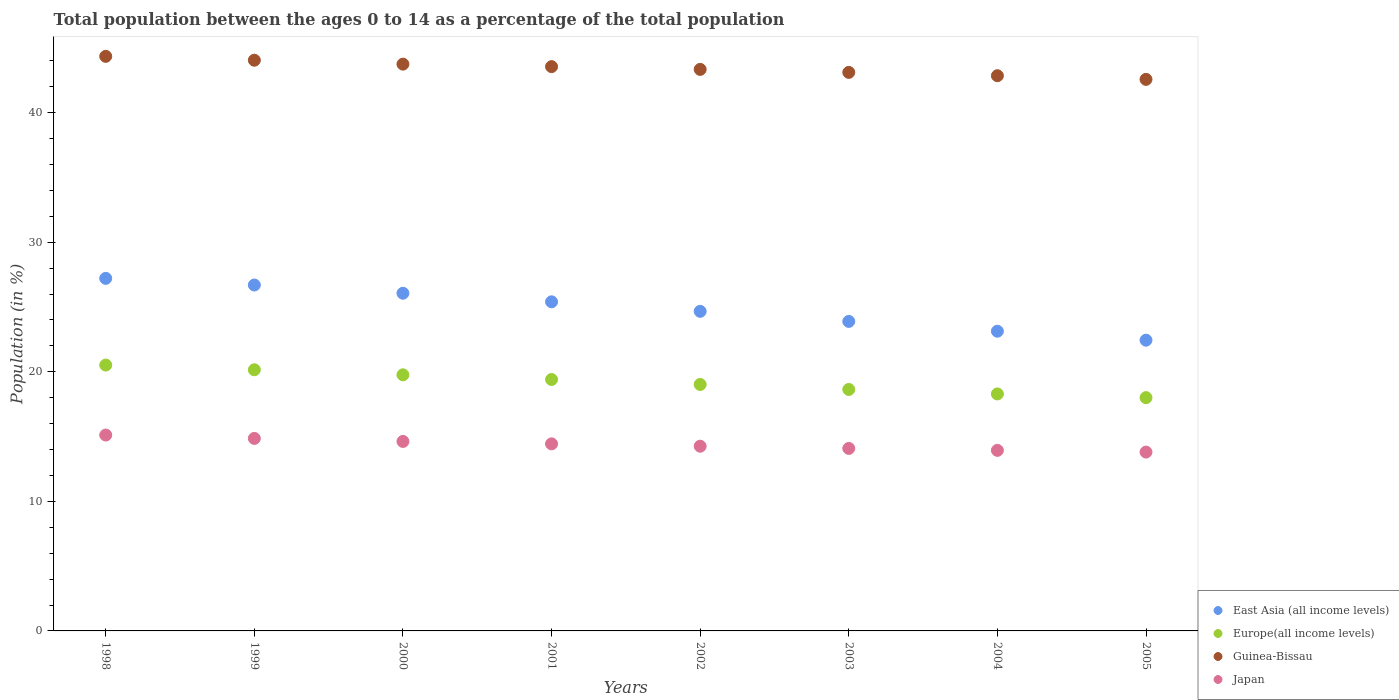How many different coloured dotlines are there?
Keep it short and to the point. 4. What is the percentage of the population ages 0 to 14 in Guinea-Bissau in 2004?
Your response must be concise. 42.85. Across all years, what is the maximum percentage of the population ages 0 to 14 in Europe(all income levels)?
Ensure brevity in your answer.  20.52. Across all years, what is the minimum percentage of the population ages 0 to 14 in Japan?
Your response must be concise. 13.8. In which year was the percentage of the population ages 0 to 14 in Guinea-Bissau maximum?
Your answer should be compact. 1998. In which year was the percentage of the population ages 0 to 14 in East Asia (all income levels) minimum?
Ensure brevity in your answer.  2005. What is the total percentage of the population ages 0 to 14 in Japan in the graph?
Your answer should be very brief. 115.12. What is the difference between the percentage of the population ages 0 to 14 in Guinea-Bissau in 2000 and that in 2003?
Your response must be concise. 0.64. What is the difference between the percentage of the population ages 0 to 14 in Guinea-Bissau in 1998 and the percentage of the population ages 0 to 14 in East Asia (all income levels) in 2002?
Offer a very short reply. 19.68. What is the average percentage of the population ages 0 to 14 in East Asia (all income levels) per year?
Offer a terse response. 24.94. In the year 1998, what is the difference between the percentage of the population ages 0 to 14 in Guinea-Bissau and percentage of the population ages 0 to 14 in East Asia (all income levels)?
Keep it short and to the point. 17.13. In how many years, is the percentage of the population ages 0 to 14 in Europe(all income levels) greater than 6?
Ensure brevity in your answer.  8. What is the ratio of the percentage of the population ages 0 to 14 in Japan in 1998 to that in 1999?
Provide a succinct answer. 1.02. Is the percentage of the population ages 0 to 14 in Europe(all income levels) in 2000 less than that in 2002?
Offer a very short reply. No. What is the difference between the highest and the second highest percentage of the population ages 0 to 14 in Japan?
Offer a very short reply. 0.26. What is the difference between the highest and the lowest percentage of the population ages 0 to 14 in East Asia (all income levels)?
Provide a succinct answer. 4.77. In how many years, is the percentage of the population ages 0 to 14 in Europe(all income levels) greater than the average percentage of the population ages 0 to 14 in Europe(all income levels) taken over all years?
Provide a succinct answer. 4. Is it the case that in every year, the sum of the percentage of the population ages 0 to 14 in Europe(all income levels) and percentage of the population ages 0 to 14 in Guinea-Bissau  is greater than the percentage of the population ages 0 to 14 in East Asia (all income levels)?
Give a very brief answer. Yes. What is the difference between two consecutive major ticks on the Y-axis?
Offer a very short reply. 10. Does the graph contain grids?
Give a very brief answer. No. How many legend labels are there?
Provide a short and direct response. 4. How are the legend labels stacked?
Make the answer very short. Vertical. What is the title of the graph?
Give a very brief answer. Total population between the ages 0 to 14 as a percentage of the total population. Does "Dominica" appear as one of the legend labels in the graph?
Your response must be concise. No. What is the label or title of the Y-axis?
Your response must be concise. Population (in %). What is the Population (in %) in East Asia (all income levels) in 1998?
Your answer should be very brief. 27.21. What is the Population (in %) in Europe(all income levels) in 1998?
Provide a short and direct response. 20.52. What is the Population (in %) in Guinea-Bissau in 1998?
Give a very brief answer. 44.34. What is the Population (in %) in Japan in 1998?
Offer a very short reply. 15.12. What is the Population (in %) of East Asia (all income levels) in 1999?
Give a very brief answer. 26.7. What is the Population (in %) of Europe(all income levels) in 1999?
Give a very brief answer. 20.16. What is the Population (in %) in Guinea-Bissau in 1999?
Your answer should be very brief. 44.05. What is the Population (in %) in Japan in 1999?
Your answer should be very brief. 14.86. What is the Population (in %) in East Asia (all income levels) in 2000?
Give a very brief answer. 26.06. What is the Population (in %) in Europe(all income levels) in 2000?
Give a very brief answer. 19.77. What is the Population (in %) of Guinea-Bissau in 2000?
Offer a terse response. 43.74. What is the Population (in %) in Japan in 2000?
Offer a very short reply. 14.62. What is the Population (in %) of East Asia (all income levels) in 2001?
Give a very brief answer. 25.4. What is the Population (in %) of Europe(all income levels) in 2001?
Your answer should be compact. 19.41. What is the Population (in %) of Guinea-Bissau in 2001?
Your answer should be very brief. 43.55. What is the Population (in %) of Japan in 2001?
Offer a terse response. 14.44. What is the Population (in %) of East Asia (all income levels) in 2002?
Give a very brief answer. 24.67. What is the Population (in %) of Europe(all income levels) in 2002?
Your answer should be very brief. 19.02. What is the Population (in %) in Guinea-Bissau in 2002?
Ensure brevity in your answer.  43.34. What is the Population (in %) of Japan in 2002?
Offer a very short reply. 14.26. What is the Population (in %) in East Asia (all income levels) in 2003?
Offer a very short reply. 23.89. What is the Population (in %) in Europe(all income levels) in 2003?
Your answer should be very brief. 18.64. What is the Population (in %) of Guinea-Bissau in 2003?
Provide a short and direct response. 43.11. What is the Population (in %) in Japan in 2003?
Your response must be concise. 14.09. What is the Population (in %) of East Asia (all income levels) in 2004?
Your response must be concise. 23.13. What is the Population (in %) of Europe(all income levels) in 2004?
Keep it short and to the point. 18.29. What is the Population (in %) of Guinea-Bissau in 2004?
Your answer should be compact. 42.85. What is the Population (in %) in Japan in 2004?
Give a very brief answer. 13.94. What is the Population (in %) in East Asia (all income levels) in 2005?
Keep it short and to the point. 22.44. What is the Population (in %) of Europe(all income levels) in 2005?
Keep it short and to the point. 18. What is the Population (in %) in Guinea-Bissau in 2005?
Provide a succinct answer. 42.57. What is the Population (in %) in Japan in 2005?
Provide a short and direct response. 13.8. Across all years, what is the maximum Population (in %) of East Asia (all income levels)?
Ensure brevity in your answer.  27.21. Across all years, what is the maximum Population (in %) in Europe(all income levels)?
Your answer should be compact. 20.52. Across all years, what is the maximum Population (in %) in Guinea-Bissau?
Ensure brevity in your answer.  44.34. Across all years, what is the maximum Population (in %) of Japan?
Keep it short and to the point. 15.12. Across all years, what is the minimum Population (in %) of East Asia (all income levels)?
Make the answer very short. 22.44. Across all years, what is the minimum Population (in %) in Europe(all income levels)?
Keep it short and to the point. 18. Across all years, what is the minimum Population (in %) in Guinea-Bissau?
Your answer should be very brief. 42.57. Across all years, what is the minimum Population (in %) of Japan?
Your answer should be compact. 13.8. What is the total Population (in %) in East Asia (all income levels) in the graph?
Your response must be concise. 199.5. What is the total Population (in %) of Europe(all income levels) in the graph?
Ensure brevity in your answer.  153.8. What is the total Population (in %) in Guinea-Bissau in the graph?
Your answer should be very brief. 347.55. What is the total Population (in %) of Japan in the graph?
Give a very brief answer. 115.12. What is the difference between the Population (in %) in East Asia (all income levels) in 1998 and that in 1999?
Your response must be concise. 0.51. What is the difference between the Population (in %) of Europe(all income levels) in 1998 and that in 1999?
Keep it short and to the point. 0.36. What is the difference between the Population (in %) in Guinea-Bissau in 1998 and that in 1999?
Your response must be concise. 0.3. What is the difference between the Population (in %) of Japan in 1998 and that in 1999?
Offer a terse response. 0.26. What is the difference between the Population (in %) in East Asia (all income levels) in 1998 and that in 2000?
Keep it short and to the point. 1.15. What is the difference between the Population (in %) of Europe(all income levels) in 1998 and that in 2000?
Your answer should be very brief. 0.75. What is the difference between the Population (in %) of Guinea-Bissau in 1998 and that in 2000?
Your response must be concise. 0.6. What is the difference between the Population (in %) in Japan in 1998 and that in 2000?
Offer a very short reply. 0.49. What is the difference between the Population (in %) of East Asia (all income levels) in 1998 and that in 2001?
Make the answer very short. 1.81. What is the difference between the Population (in %) of Europe(all income levels) in 1998 and that in 2001?
Your answer should be very brief. 1.11. What is the difference between the Population (in %) in Guinea-Bissau in 1998 and that in 2001?
Offer a terse response. 0.79. What is the difference between the Population (in %) of Japan in 1998 and that in 2001?
Ensure brevity in your answer.  0.68. What is the difference between the Population (in %) in East Asia (all income levels) in 1998 and that in 2002?
Give a very brief answer. 2.54. What is the difference between the Population (in %) of Europe(all income levels) in 1998 and that in 2002?
Provide a succinct answer. 1.5. What is the difference between the Population (in %) in Guinea-Bissau in 1998 and that in 2002?
Give a very brief answer. 1.01. What is the difference between the Population (in %) of Japan in 1998 and that in 2002?
Provide a succinct answer. 0.86. What is the difference between the Population (in %) of East Asia (all income levels) in 1998 and that in 2003?
Provide a short and direct response. 3.32. What is the difference between the Population (in %) of Europe(all income levels) in 1998 and that in 2003?
Offer a very short reply. 1.88. What is the difference between the Population (in %) of Guinea-Bissau in 1998 and that in 2003?
Provide a short and direct response. 1.24. What is the difference between the Population (in %) in Japan in 1998 and that in 2003?
Your answer should be very brief. 1.03. What is the difference between the Population (in %) of East Asia (all income levels) in 1998 and that in 2004?
Offer a very short reply. 4.08. What is the difference between the Population (in %) of Europe(all income levels) in 1998 and that in 2004?
Provide a succinct answer. 2.23. What is the difference between the Population (in %) in Guinea-Bissau in 1998 and that in 2004?
Make the answer very short. 1.49. What is the difference between the Population (in %) in Japan in 1998 and that in 2004?
Make the answer very short. 1.18. What is the difference between the Population (in %) in East Asia (all income levels) in 1998 and that in 2005?
Your answer should be compact. 4.77. What is the difference between the Population (in %) of Europe(all income levels) in 1998 and that in 2005?
Provide a succinct answer. 2.51. What is the difference between the Population (in %) in Guinea-Bissau in 1998 and that in 2005?
Your response must be concise. 1.78. What is the difference between the Population (in %) of Japan in 1998 and that in 2005?
Your answer should be compact. 1.31. What is the difference between the Population (in %) in East Asia (all income levels) in 1999 and that in 2000?
Ensure brevity in your answer.  0.64. What is the difference between the Population (in %) of Europe(all income levels) in 1999 and that in 2000?
Your response must be concise. 0.39. What is the difference between the Population (in %) of Guinea-Bissau in 1999 and that in 2000?
Provide a succinct answer. 0.3. What is the difference between the Population (in %) of Japan in 1999 and that in 2000?
Keep it short and to the point. 0.23. What is the difference between the Population (in %) of East Asia (all income levels) in 1999 and that in 2001?
Ensure brevity in your answer.  1.3. What is the difference between the Population (in %) in Europe(all income levels) in 1999 and that in 2001?
Keep it short and to the point. 0.75. What is the difference between the Population (in %) in Guinea-Bissau in 1999 and that in 2001?
Make the answer very short. 0.49. What is the difference between the Population (in %) in Japan in 1999 and that in 2001?
Offer a terse response. 0.42. What is the difference between the Population (in %) of East Asia (all income levels) in 1999 and that in 2002?
Your answer should be compact. 2.03. What is the difference between the Population (in %) of Europe(all income levels) in 1999 and that in 2002?
Keep it short and to the point. 1.13. What is the difference between the Population (in %) of Guinea-Bissau in 1999 and that in 2002?
Offer a very short reply. 0.71. What is the difference between the Population (in %) in Japan in 1999 and that in 2002?
Offer a very short reply. 0.6. What is the difference between the Population (in %) of East Asia (all income levels) in 1999 and that in 2003?
Ensure brevity in your answer.  2.81. What is the difference between the Population (in %) in Europe(all income levels) in 1999 and that in 2003?
Your answer should be compact. 1.52. What is the difference between the Population (in %) of Guinea-Bissau in 1999 and that in 2003?
Give a very brief answer. 0.94. What is the difference between the Population (in %) in Japan in 1999 and that in 2003?
Provide a succinct answer. 0.77. What is the difference between the Population (in %) of East Asia (all income levels) in 1999 and that in 2004?
Your answer should be very brief. 3.57. What is the difference between the Population (in %) in Europe(all income levels) in 1999 and that in 2004?
Your answer should be very brief. 1.87. What is the difference between the Population (in %) in Guinea-Bissau in 1999 and that in 2004?
Keep it short and to the point. 1.2. What is the difference between the Population (in %) in Japan in 1999 and that in 2004?
Your response must be concise. 0.92. What is the difference between the Population (in %) in East Asia (all income levels) in 1999 and that in 2005?
Your answer should be very brief. 4.26. What is the difference between the Population (in %) of Europe(all income levels) in 1999 and that in 2005?
Ensure brevity in your answer.  2.15. What is the difference between the Population (in %) in Guinea-Bissau in 1999 and that in 2005?
Your answer should be compact. 1.48. What is the difference between the Population (in %) in Japan in 1999 and that in 2005?
Give a very brief answer. 1.05. What is the difference between the Population (in %) of East Asia (all income levels) in 2000 and that in 2001?
Ensure brevity in your answer.  0.66. What is the difference between the Population (in %) of Europe(all income levels) in 2000 and that in 2001?
Provide a succinct answer. 0.36. What is the difference between the Population (in %) of Guinea-Bissau in 2000 and that in 2001?
Provide a succinct answer. 0.19. What is the difference between the Population (in %) in Japan in 2000 and that in 2001?
Ensure brevity in your answer.  0.19. What is the difference between the Population (in %) of East Asia (all income levels) in 2000 and that in 2002?
Your answer should be compact. 1.4. What is the difference between the Population (in %) of Europe(all income levels) in 2000 and that in 2002?
Your answer should be compact. 0.74. What is the difference between the Population (in %) of Guinea-Bissau in 2000 and that in 2002?
Your answer should be compact. 0.41. What is the difference between the Population (in %) of Japan in 2000 and that in 2002?
Offer a very short reply. 0.37. What is the difference between the Population (in %) in East Asia (all income levels) in 2000 and that in 2003?
Provide a short and direct response. 2.18. What is the difference between the Population (in %) in Europe(all income levels) in 2000 and that in 2003?
Give a very brief answer. 1.13. What is the difference between the Population (in %) in Guinea-Bissau in 2000 and that in 2003?
Your response must be concise. 0.64. What is the difference between the Population (in %) in Japan in 2000 and that in 2003?
Offer a terse response. 0.54. What is the difference between the Population (in %) in East Asia (all income levels) in 2000 and that in 2004?
Your answer should be very brief. 2.93. What is the difference between the Population (in %) of Europe(all income levels) in 2000 and that in 2004?
Keep it short and to the point. 1.48. What is the difference between the Population (in %) of Guinea-Bissau in 2000 and that in 2004?
Provide a short and direct response. 0.89. What is the difference between the Population (in %) of Japan in 2000 and that in 2004?
Make the answer very short. 0.69. What is the difference between the Population (in %) in East Asia (all income levels) in 2000 and that in 2005?
Keep it short and to the point. 3.62. What is the difference between the Population (in %) of Europe(all income levels) in 2000 and that in 2005?
Give a very brief answer. 1.76. What is the difference between the Population (in %) of Guinea-Bissau in 2000 and that in 2005?
Offer a very short reply. 1.18. What is the difference between the Population (in %) of Japan in 2000 and that in 2005?
Your answer should be very brief. 0.82. What is the difference between the Population (in %) in East Asia (all income levels) in 2001 and that in 2002?
Provide a short and direct response. 0.73. What is the difference between the Population (in %) in Europe(all income levels) in 2001 and that in 2002?
Offer a terse response. 0.38. What is the difference between the Population (in %) in Guinea-Bissau in 2001 and that in 2002?
Ensure brevity in your answer.  0.21. What is the difference between the Population (in %) in Japan in 2001 and that in 2002?
Your response must be concise. 0.18. What is the difference between the Population (in %) of East Asia (all income levels) in 2001 and that in 2003?
Your answer should be compact. 1.51. What is the difference between the Population (in %) of Europe(all income levels) in 2001 and that in 2003?
Give a very brief answer. 0.77. What is the difference between the Population (in %) in Guinea-Bissau in 2001 and that in 2003?
Offer a very short reply. 0.44. What is the difference between the Population (in %) in Japan in 2001 and that in 2003?
Provide a succinct answer. 0.35. What is the difference between the Population (in %) of East Asia (all income levels) in 2001 and that in 2004?
Provide a short and direct response. 2.27. What is the difference between the Population (in %) of Europe(all income levels) in 2001 and that in 2004?
Your answer should be very brief. 1.12. What is the difference between the Population (in %) in Guinea-Bissau in 2001 and that in 2004?
Make the answer very short. 0.7. What is the difference between the Population (in %) of Japan in 2001 and that in 2004?
Your response must be concise. 0.5. What is the difference between the Population (in %) in East Asia (all income levels) in 2001 and that in 2005?
Provide a succinct answer. 2.96. What is the difference between the Population (in %) of Europe(all income levels) in 2001 and that in 2005?
Give a very brief answer. 1.4. What is the difference between the Population (in %) in Guinea-Bissau in 2001 and that in 2005?
Offer a terse response. 0.98. What is the difference between the Population (in %) in Japan in 2001 and that in 2005?
Keep it short and to the point. 0.63. What is the difference between the Population (in %) in East Asia (all income levels) in 2002 and that in 2003?
Your response must be concise. 0.78. What is the difference between the Population (in %) in Europe(all income levels) in 2002 and that in 2003?
Provide a succinct answer. 0.39. What is the difference between the Population (in %) of Guinea-Bissau in 2002 and that in 2003?
Give a very brief answer. 0.23. What is the difference between the Population (in %) in Japan in 2002 and that in 2003?
Provide a succinct answer. 0.17. What is the difference between the Population (in %) of East Asia (all income levels) in 2002 and that in 2004?
Your answer should be very brief. 1.53. What is the difference between the Population (in %) in Europe(all income levels) in 2002 and that in 2004?
Offer a terse response. 0.73. What is the difference between the Population (in %) of Guinea-Bissau in 2002 and that in 2004?
Give a very brief answer. 0.49. What is the difference between the Population (in %) in Japan in 2002 and that in 2004?
Provide a short and direct response. 0.32. What is the difference between the Population (in %) in East Asia (all income levels) in 2002 and that in 2005?
Offer a terse response. 2.23. What is the difference between the Population (in %) of Europe(all income levels) in 2002 and that in 2005?
Keep it short and to the point. 1.02. What is the difference between the Population (in %) of Guinea-Bissau in 2002 and that in 2005?
Your answer should be very brief. 0.77. What is the difference between the Population (in %) of Japan in 2002 and that in 2005?
Give a very brief answer. 0.45. What is the difference between the Population (in %) in East Asia (all income levels) in 2003 and that in 2004?
Your answer should be compact. 0.76. What is the difference between the Population (in %) in Europe(all income levels) in 2003 and that in 2004?
Give a very brief answer. 0.35. What is the difference between the Population (in %) of Guinea-Bissau in 2003 and that in 2004?
Make the answer very short. 0.26. What is the difference between the Population (in %) of Japan in 2003 and that in 2004?
Your answer should be compact. 0.15. What is the difference between the Population (in %) of East Asia (all income levels) in 2003 and that in 2005?
Your response must be concise. 1.45. What is the difference between the Population (in %) in Europe(all income levels) in 2003 and that in 2005?
Provide a short and direct response. 0.63. What is the difference between the Population (in %) of Guinea-Bissau in 2003 and that in 2005?
Offer a terse response. 0.54. What is the difference between the Population (in %) in Japan in 2003 and that in 2005?
Ensure brevity in your answer.  0.28. What is the difference between the Population (in %) in East Asia (all income levels) in 2004 and that in 2005?
Your answer should be compact. 0.69. What is the difference between the Population (in %) of Europe(all income levels) in 2004 and that in 2005?
Keep it short and to the point. 0.28. What is the difference between the Population (in %) of Guinea-Bissau in 2004 and that in 2005?
Provide a succinct answer. 0.28. What is the difference between the Population (in %) of Japan in 2004 and that in 2005?
Offer a very short reply. 0.13. What is the difference between the Population (in %) in East Asia (all income levels) in 1998 and the Population (in %) in Europe(all income levels) in 1999?
Keep it short and to the point. 7.05. What is the difference between the Population (in %) of East Asia (all income levels) in 1998 and the Population (in %) of Guinea-Bissau in 1999?
Your answer should be very brief. -16.84. What is the difference between the Population (in %) in East Asia (all income levels) in 1998 and the Population (in %) in Japan in 1999?
Provide a short and direct response. 12.35. What is the difference between the Population (in %) in Europe(all income levels) in 1998 and the Population (in %) in Guinea-Bissau in 1999?
Offer a terse response. -23.53. What is the difference between the Population (in %) of Europe(all income levels) in 1998 and the Population (in %) of Japan in 1999?
Offer a terse response. 5.66. What is the difference between the Population (in %) of Guinea-Bissau in 1998 and the Population (in %) of Japan in 1999?
Your answer should be compact. 29.49. What is the difference between the Population (in %) of East Asia (all income levels) in 1998 and the Population (in %) of Europe(all income levels) in 2000?
Offer a terse response. 7.44. What is the difference between the Population (in %) in East Asia (all income levels) in 1998 and the Population (in %) in Guinea-Bissau in 2000?
Your answer should be very brief. -16.53. What is the difference between the Population (in %) in East Asia (all income levels) in 1998 and the Population (in %) in Japan in 2000?
Your answer should be very brief. 12.59. What is the difference between the Population (in %) of Europe(all income levels) in 1998 and the Population (in %) of Guinea-Bissau in 2000?
Your answer should be very brief. -23.23. What is the difference between the Population (in %) of Europe(all income levels) in 1998 and the Population (in %) of Japan in 2000?
Provide a succinct answer. 5.89. What is the difference between the Population (in %) of Guinea-Bissau in 1998 and the Population (in %) of Japan in 2000?
Give a very brief answer. 29.72. What is the difference between the Population (in %) in East Asia (all income levels) in 1998 and the Population (in %) in Europe(all income levels) in 2001?
Offer a terse response. 7.8. What is the difference between the Population (in %) in East Asia (all income levels) in 1998 and the Population (in %) in Guinea-Bissau in 2001?
Make the answer very short. -16.34. What is the difference between the Population (in %) in East Asia (all income levels) in 1998 and the Population (in %) in Japan in 2001?
Make the answer very short. 12.77. What is the difference between the Population (in %) of Europe(all income levels) in 1998 and the Population (in %) of Guinea-Bissau in 2001?
Your response must be concise. -23.03. What is the difference between the Population (in %) of Europe(all income levels) in 1998 and the Population (in %) of Japan in 2001?
Provide a short and direct response. 6.08. What is the difference between the Population (in %) of Guinea-Bissau in 1998 and the Population (in %) of Japan in 2001?
Your answer should be very brief. 29.91. What is the difference between the Population (in %) in East Asia (all income levels) in 1998 and the Population (in %) in Europe(all income levels) in 2002?
Provide a short and direct response. 8.19. What is the difference between the Population (in %) of East Asia (all income levels) in 1998 and the Population (in %) of Guinea-Bissau in 2002?
Your response must be concise. -16.13. What is the difference between the Population (in %) in East Asia (all income levels) in 1998 and the Population (in %) in Japan in 2002?
Offer a very short reply. 12.95. What is the difference between the Population (in %) in Europe(all income levels) in 1998 and the Population (in %) in Guinea-Bissau in 2002?
Provide a short and direct response. -22.82. What is the difference between the Population (in %) of Europe(all income levels) in 1998 and the Population (in %) of Japan in 2002?
Ensure brevity in your answer.  6.26. What is the difference between the Population (in %) in Guinea-Bissau in 1998 and the Population (in %) in Japan in 2002?
Your answer should be compact. 30.09. What is the difference between the Population (in %) of East Asia (all income levels) in 1998 and the Population (in %) of Europe(all income levels) in 2003?
Your answer should be compact. 8.57. What is the difference between the Population (in %) in East Asia (all income levels) in 1998 and the Population (in %) in Guinea-Bissau in 2003?
Ensure brevity in your answer.  -15.9. What is the difference between the Population (in %) of East Asia (all income levels) in 1998 and the Population (in %) of Japan in 2003?
Make the answer very short. 13.12. What is the difference between the Population (in %) in Europe(all income levels) in 1998 and the Population (in %) in Guinea-Bissau in 2003?
Offer a terse response. -22.59. What is the difference between the Population (in %) of Europe(all income levels) in 1998 and the Population (in %) of Japan in 2003?
Make the answer very short. 6.43. What is the difference between the Population (in %) in Guinea-Bissau in 1998 and the Population (in %) in Japan in 2003?
Offer a terse response. 30.26. What is the difference between the Population (in %) of East Asia (all income levels) in 1998 and the Population (in %) of Europe(all income levels) in 2004?
Your response must be concise. 8.92. What is the difference between the Population (in %) of East Asia (all income levels) in 1998 and the Population (in %) of Guinea-Bissau in 2004?
Your response must be concise. -15.64. What is the difference between the Population (in %) in East Asia (all income levels) in 1998 and the Population (in %) in Japan in 2004?
Give a very brief answer. 13.28. What is the difference between the Population (in %) of Europe(all income levels) in 1998 and the Population (in %) of Guinea-Bissau in 2004?
Your answer should be compact. -22.33. What is the difference between the Population (in %) of Europe(all income levels) in 1998 and the Population (in %) of Japan in 2004?
Give a very brief answer. 6.58. What is the difference between the Population (in %) of Guinea-Bissau in 1998 and the Population (in %) of Japan in 2004?
Provide a succinct answer. 30.41. What is the difference between the Population (in %) in East Asia (all income levels) in 1998 and the Population (in %) in Europe(all income levels) in 2005?
Offer a very short reply. 9.21. What is the difference between the Population (in %) in East Asia (all income levels) in 1998 and the Population (in %) in Guinea-Bissau in 2005?
Your answer should be compact. -15.36. What is the difference between the Population (in %) in East Asia (all income levels) in 1998 and the Population (in %) in Japan in 2005?
Provide a succinct answer. 13.41. What is the difference between the Population (in %) of Europe(all income levels) in 1998 and the Population (in %) of Guinea-Bissau in 2005?
Your answer should be compact. -22.05. What is the difference between the Population (in %) in Europe(all income levels) in 1998 and the Population (in %) in Japan in 2005?
Give a very brief answer. 6.72. What is the difference between the Population (in %) in Guinea-Bissau in 1998 and the Population (in %) in Japan in 2005?
Ensure brevity in your answer.  30.54. What is the difference between the Population (in %) in East Asia (all income levels) in 1999 and the Population (in %) in Europe(all income levels) in 2000?
Provide a succinct answer. 6.93. What is the difference between the Population (in %) in East Asia (all income levels) in 1999 and the Population (in %) in Guinea-Bissau in 2000?
Offer a very short reply. -17.05. What is the difference between the Population (in %) in East Asia (all income levels) in 1999 and the Population (in %) in Japan in 2000?
Offer a terse response. 12.07. What is the difference between the Population (in %) of Europe(all income levels) in 1999 and the Population (in %) of Guinea-Bissau in 2000?
Keep it short and to the point. -23.59. What is the difference between the Population (in %) of Europe(all income levels) in 1999 and the Population (in %) of Japan in 2000?
Your answer should be compact. 5.53. What is the difference between the Population (in %) of Guinea-Bissau in 1999 and the Population (in %) of Japan in 2000?
Your answer should be very brief. 29.42. What is the difference between the Population (in %) in East Asia (all income levels) in 1999 and the Population (in %) in Europe(all income levels) in 2001?
Offer a very short reply. 7.29. What is the difference between the Population (in %) in East Asia (all income levels) in 1999 and the Population (in %) in Guinea-Bissau in 2001?
Make the answer very short. -16.85. What is the difference between the Population (in %) in East Asia (all income levels) in 1999 and the Population (in %) in Japan in 2001?
Keep it short and to the point. 12.26. What is the difference between the Population (in %) of Europe(all income levels) in 1999 and the Population (in %) of Guinea-Bissau in 2001?
Ensure brevity in your answer.  -23.4. What is the difference between the Population (in %) of Europe(all income levels) in 1999 and the Population (in %) of Japan in 2001?
Your answer should be very brief. 5.72. What is the difference between the Population (in %) of Guinea-Bissau in 1999 and the Population (in %) of Japan in 2001?
Offer a terse response. 29.61. What is the difference between the Population (in %) in East Asia (all income levels) in 1999 and the Population (in %) in Europe(all income levels) in 2002?
Your response must be concise. 7.68. What is the difference between the Population (in %) of East Asia (all income levels) in 1999 and the Population (in %) of Guinea-Bissau in 2002?
Give a very brief answer. -16.64. What is the difference between the Population (in %) in East Asia (all income levels) in 1999 and the Population (in %) in Japan in 2002?
Offer a very short reply. 12.44. What is the difference between the Population (in %) of Europe(all income levels) in 1999 and the Population (in %) of Guinea-Bissau in 2002?
Offer a very short reply. -23.18. What is the difference between the Population (in %) in Europe(all income levels) in 1999 and the Population (in %) in Japan in 2002?
Your response must be concise. 5.9. What is the difference between the Population (in %) of Guinea-Bissau in 1999 and the Population (in %) of Japan in 2002?
Offer a very short reply. 29.79. What is the difference between the Population (in %) of East Asia (all income levels) in 1999 and the Population (in %) of Europe(all income levels) in 2003?
Provide a succinct answer. 8.06. What is the difference between the Population (in %) of East Asia (all income levels) in 1999 and the Population (in %) of Guinea-Bissau in 2003?
Offer a terse response. -16.41. What is the difference between the Population (in %) in East Asia (all income levels) in 1999 and the Population (in %) in Japan in 2003?
Give a very brief answer. 12.61. What is the difference between the Population (in %) in Europe(all income levels) in 1999 and the Population (in %) in Guinea-Bissau in 2003?
Your answer should be very brief. -22.95. What is the difference between the Population (in %) in Europe(all income levels) in 1999 and the Population (in %) in Japan in 2003?
Provide a short and direct response. 6.07. What is the difference between the Population (in %) of Guinea-Bissau in 1999 and the Population (in %) of Japan in 2003?
Your response must be concise. 29.96. What is the difference between the Population (in %) of East Asia (all income levels) in 1999 and the Population (in %) of Europe(all income levels) in 2004?
Offer a very short reply. 8.41. What is the difference between the Population (in %) in East Asia (all income levels) in 1999 and the Population (in %) in Guinea-Bissau in 2004?
Provide a short and direct response. -16.15. What is the difference between the Population (in %) in East Asia (all income levels) in 1999 and the Population (in %) in Japan in 2004?
Ensure brevity in your answer.  12.76. What is the difference between the Population (in %) in Europe(all income levels) in 1999 and the Population (in %) in Guinea-Bissau in 2004?
Provide a succinct answer. -22.7. What is the difference between the Population (in %) in Europe(all income levels) in 1999 and the Population (in %) in Japan in 2004?
Offer a terse response. 6.22. What is the difference between the Population (in %) in Guinea-Bissau in 1999 and the Population (in %) in Japan in 2004?
Offer a very short reply. 30.11. What is the difference between the Population (in %) of East Asia (all income levels) in 1999 and the Population (in %) of Europe(all income levels) in 2005?
Ensure brevity in your answer.  8.69. What is the difference between the Population (in %) of East Asia (all income levels) in 1999 and the Population (in %) of Guinea-Bissau in 2005?
Ensure brevity in your answer.  -15.87. What is the difference between the Population (in %) in East Asia (all income levels) in 1999 and the Population (in %) in Japan in 2005?
Provide a succinct answer. 12.89. What is the difference between the Population (in %) in Europe(all income levels) in 1999 and the Population (in %) in Guinea-Bissau in 2005?
Your answer should be very brief. -22.41. What is the difference between the Population (in %) of Europe(all income levels) in 1999 and the Population (in %) of Japan in 2005?
Your answer should be compact. 6.35. What is the difference between the Population (in %) of Guinea-Bissau in 1999 and the Population (in %) of Japan in 2005?
Your response must be concise. 30.24. What is the difference between the Population (in %) in East Asia (all income levels) in 2000 and the Population (in %) in Europe(all income levels) in 2001?
Provide a succinct answer. 6.66. What is the difference between the Population (in %) in East Asia (all income levels) in 2000 and the Population (in %) in Guinea-Bissau in 2001?
Offer a terse response. -17.49. What is the difference between the Population (in %) of East Asia (all income levels) in 2000 and the Population (in %) of Japan in 2001?
Give a very brief answer. 11.62. What is the difference between the Population (in %) in Europe(all income levels) in 2000 and the Population (in %) in Guinea-Bissau in 2001?
Provide a succinct answer. -23.79. What is the difference between the Population (in %) in Europe(all income levels) in 2000 and the Population (in %) in Japan in 2001?
Offer a terse response. 5.33. What is the difference between the Population (in %) in Guinea-Bissau in 2000 and the Population (in %) in Japan in 2001?
Your answer should be compact. 29.31. What is the difference between the Population (in %) in East Asia (all income levels) in 2000 and the Population (in %) in Europe(all income levels) in 2002?
Give a very brief answer. 7.04. What is the difference between the Population (in %) in East Asia (all income levels) in 2000 and the Population (in %) in Guinea-Bissau in 2002?
Keep it short and to the point. -17.28. What is the difference between the Population (in %) of East Asia (all income levels) in 2000 and the Population (in %) of Japan in 2002?
Provide a succinct answer. 11.81. What is the difference between the Population (in %) in Europe(all income levels) in 2000 and the Population (in %) in Guinea-Bissau in 2002?
Ensure brevity in your answer.  -23.57. What is the difference between the Population (in %) in Europe(all income levels) in 2000 and the Population (in %) in Japan in 2002?
Ensure brevity in your answer.  5.51. What is the difference between the Population (in %) of Guinea-Bissau in 2000 and the Population (in %) of Japan in 2002?
Offer a terse response. 29.49. What is the difference between the Population (in %) in East Asia (all income levels) in 2000 and the Population (in %) in Europe(all income levels) in 2003?
Offer a very short reply. 7.43. What is the difference between the Population (in %) of East Asia (all income levels) in 2000 and the Population (in %) of Guinea-Bissau in 2003?
Offer a terse response. -17.04. What is the difference between the Population (in %) of East Asia (all income levels) in 2000 and the Population (in %) of Japan in 2003?
Ensure brevity in your answer.  11.98. What is the difference between the Population (in %) of Europe(all income levels) in 2000 and the Population (in %) of Guinea-Bissau in 2003?
Offer a very short reply. -23.34. What is the difference between the Population (in %) of Europe(all income levels) in 2000 and the Population (in %) of Japan in 2003?
Provide a succinct answer. 5.68. What is the difference between the Population (in %) of Guinea-Bissau in 2000 and the Population (in %) of Japan in 2003?
Your answer should be very brief. 29.66. What is the difference between the Population (in %) in East Asia (all income levels) in 2000 and the Population (in %) in Europe(all income levels) in 2004?
Provide a short and direct response. 7.77. What is the difference between the Population (in %) in East Asia (all income levels) in 2000 and the Population (in %) in Guinea-Bissau in 2004?
Give a very brief answer. -16.79. What is the difference between the Population (in %) of East Asia (all income levels) in 2000 and the Population (in %) of Japan in 2004?
Offer a terse response. 12.13. What is the difference between the Population (in %) of Europe(all income levels) in 2000 and the Population (in %) of Guinea-Bissau in 2004?
Offer a very short reply. -23.08. What is the difference between the Population (in %) in Europe(all income levels) in 2000 and the Population (in %) in Japan in 2004?
Make the answer very short. 5.83. What is the difference between the Population (in %) of Guinea-Bissau in 2000 and the Population (in %) of Japan in 2004?
Ensure brevity in your answer.  29.81. What is the difference between the Population (in %) in East Asia (all income levels) in 2000 and the Population (in %) in Europe(all income levels) in 2005?
Keep it short and to the point. 8.06. What is the difference between the Population (in %) in East Asia (all income levels) in 2000 and the Population (in %) in Guinea-Bissau in 2005?
Offer a very short reply. -16.51. What is the difference between the Population (in %) of East Asia (all income levels) in 2000 and the Population (in %) of Japan in 2005?
Provide a succinct answer. 12.26. What is the difference between the Population (in %) in Europe(all income levels) in 2000 and the Population (in %) in Guinea-Bissau in 2005?
Provide a succinct answer. -22.8. What is the difference between the Population (in %) of Europe(all income levels) in 2000 and the Population (in %) of Japan in 2005?
Make the answer very short. 5.96. What is the difference between the Population (in %) of Guinea-Bissau in 2000 and the Population (in %) of Japan in 2005?
Your answer should be compact. 29.94. What is the difference between the Population (in %) of East Asia (all income levels) in 2001 and the Population (in %) of Europe(all income levels) in 2002?
Keep it short and to the point. 6.38. What is the difference between the Population (in %) of East Asia (all income levels) in 2001 and the Population (in %) of Guinea-Bissau in 2002?
Give a very brief answer. -17.94. What is the difference between the Population (in %) of East Asia (all income levels) in 2001 and the Population (in %) of Japan in 2002?
Make the answer very short. 11.14. What is the difference between the Population (in %) of Europe(all income levels) in 2001 and the Population (in %) of Guinea-Bissau in 2002?
Provide a short and direct response. -23.93. What is the difference between the Population (in %) in Europe(all income levels) in 2001 and the Population (in %) in Japan in 2002?
Offer a very short reply. 5.15. What is the difference between the Population (in %) of Guinea-Bissau in 2001 and the Population (in %) of Japan in 2002?
Your answer should be compact. 29.3. What is the difference between the Population (in %) of East Asia (all income levels) in 2001 and the Population (in %) of Europe(all income levels) in 2003?
Your answer should be very brief. 6.76. What is the difference between the Population (in %) in East Asia (all income levels) in 2001 and the Population (in %) in Guinea-Bissau in 2003?
Your answer should be compact. -17.71. What is the difference between the Population (in %) of East Asia (all income levels) in 2001 and the Population (in %) of Japan in 2003?
Keep it short and to the point. 11.31. What is the difference between the Population (in %) of Europe(all income levels) in 2001 and the Population (in %) of Guinea-Bissau in 2003?
Make the answer very short. -23.7. What is the difference between the Population (in %) in Europe(all income levels) in 2001 and the Population (in %) in Japan in 2003?
Offer a very short reply. 5.32. What is the difference between the Population (in %) in Guinea-Bissau in 2001 and the Population (in %) in Japan in 2003?
Ensure brevity in your answer.  29.47. What is the difference between the Population (in %) of East Asia (all income levels) in 2001 and the Population (in %) of Europe(all income levels) in 2004?
Provide a short and direct response. 7.11. What is the difference between the Population (in %) in East Asia (all income levels) in 2001 and the Population (in %) in Guinea-Bissau in 2004?
Offer a very short reply. -17.45. What is the difference between the Population (in %) in East Asia (all income levels) in 2001 and the Population (in %) in Japan in 2004?
Ensure brevity in your answer.  11.46. What is the difference between the Population (in %) in Europe(all income levels) in 2001 and the Population (in %) in Guinea-Bissau in 2004?
Ensure brevity in your answer.  -23.45. What is the difference between the Population (in %) in Europe(all income levels) in 2001 and the Population (in %) in Japan in 2004?
Offer a terse response. 5.47. What is the difference between the Population (in %) of Guinea-Bissau in 2001 and the Population (in %) of Japan in 2004?
Offer a very short reply. 29.62. What is the difference between the Population (in %) of East Asia (all income levels) in 2001 and the Population (in %) of Europe(all income levels) in 2005?
Give a very brief answer. 7.4. What is the difference between the Population (in %) in East Asia (all income levels) in 2001 and the Population (in %) in Guinea-Bissau in 2005?
Ensure brevity in your answer.  -17.17. What is the difference between the Population (in %) of East Asia (all income levels) in 2001 and the Population (in %) of Japan in 2005?
Your answer should be very brief. 11.6. What is the difference between the Population (in %) of Europe(all income levels) in 2001 and the Population (in %) of Guinea-Bissau in 2005?
Provide a succinct answer. -23.16. What is the difference between the Population (in %) of Europe(all income levels) in 2001 and the Population (in %) of Japan in 2005?
Ensure brevity in your answer.  5.6. What is the difference between the Population (in %) in Guinea-Bissau in 2001 and the Population (in %) in Japan in 2005?
Ensure brevity in your answer.  29.75. What is the difference between the Population (in %) in East Asia (all income levels) in 2002 and the Population (in %) in Europe(all income levels) in 2003?
Ensure brevity in your answer.  6.03. What is the difference between the Population (in %) in East Asia (all income levels) in 2002 and the Population (in %) in Guinea-Bissau in 2003?
Ensure brevity in your answer.  -18.44. What is the difference between the Population (in %) of East Asia (all income levels) in 2002 and the Population (in %) of Japan in 2003?
Your response must be concise. 10.58. What is the difference between the Population (in %) of Europe(all income levels) in 2002 and the Population (in %) of Guinea-Bissau in 2003?
Your answer should be very brief. -24.09. What is the difference between the Population (in %) of Europe(all income levels) in 2002 and the Population (in %) of Japan in 2003?
Provide a succinct answer. 4.94. What is the difference between the Population (in %) of Guinea-Bissau in 2002 and the Population (in %) of Japan in 2003?
Your response must be concise. 29.25. What is the difference between the Population (in %) of East Asia (all income levels) in 2002 and the Population (in %) of Europe(all income levels) in 2004?
Provide a succinct answer. 6.38. What is the difference between the Population (in %) in East Asia (all income levels) in 2002 and the Population (in %) in Guinea-Bissau in 2004?
Make the answer very short. -18.19. What is the difference between the Population (in %) of East Asia (all income levels) in 2002 and the Population (in %) of Japan in 2004?
Offer a terse response. 10.73. What is the difference between the Population (in %) of Europe(all income levels) in 2002 and the Population (in %) of Guinea-Bissau in 2004?
Provide a short and direct response. -23.83. What is the difference between the Population (in %) in Europe(all income levels) in 2002 and the Population (in %) in Japan in 2004?
Your answer should be compact. 5.09. What is the difference between the Population (in %) in Guinea-Bissau in 2002 and the Population (in %) in Japan in 2004?
Make the answer very short. 29.4. What is the difference between the Population (in %) in East Asia (all income levels) in 2002 and the Population (in %) in Europe(all income levels) in 2005?
Offer a terse response. 6.66. What is the difference between the Population (in %) of East Asia (all income levels) in 2002 and the Population (in %) of Guinea-Bissau in 2005?
Your answer should be compact. -17.9. What is the difference between the Population (in %) of East Asia (all income levels) in 2002 and the Population (in %) of Japan in 2005?
Make the answer very short. 10.86. What is the difference between the Population (in %) of Europe(all income levels) in 2002 and the Population (in %) of Guinea-Bissau in 2005?
Your answer should be compact. -23.55. What is the difference between the Population (in %) of Europe(all income levels) in 2002 and the Population (in %) of Japan in 2005?
Make the answer very short. 5.22. What is the difference between the Population (in %) in Guinea-Bissau in 2002 and the Population (in %) in Japan in 2005?
Provide a short and direct response. 29.53. What is the difference between the Population (in %) of East Asia (all income levels) in 2003 and the Population (in %) of Europe(all income levels) in 2004?
Your answer should be very brief. 5.6. What is the difference between the Population (in %) in East Asia (all income levels) in 2003 and the Population (in %) in Guinea-Bissau in 2004?
Your answer should be very brief. -18.96. What is the difference between the Population (in %) of East Asia (all income levels) in 2003 and the Population (in %) of Japan in 2004?
Your answer should be compact. 9.95. What is the difference between the Population (in %) in Europe(all income levels) in 2003 and the Population (in %) in Guinea-Bissau in 2004?
Offer a terse response. -24.22. What is the difference between the Population (in %) of Europe(all income levels) in 2003 and the Population (in %) of Japan in 2004?
Your answer should be compact. 4.7. What is the difference between the Population (in %) of Guinea-Bissau in 2003 and the Population (in %) of Japan in 2004?
Offer a terse response. 29.17. What is the difference between the Population (in %) of East Asia (all income levels) in 2003 and the Population (in %) of Europe(all income levels) in 2005?
Your answer should be compact. 5.88. What is the difference between the Population (in %) of East Asia (all income levels) in 2003 and the Population (in %) of Guinea-Bissau in 2005?
Your response must be concise. -18.68. What is the difference between the Population (in %) in East Asia (all income levels) in 2003 and the Population (in %) in Japan in 2005?
Make the answer very short. 10.08. What is the difference between the Population (in %) of Europe(all income levels) in 2003 and the Population (in %) of Guinea-Bissau in 2005?
Your answer should be compact. -23.93. What is the difference between the Population (in %) of Europe(all income levels) in 2003 and the Population (in %) of Japan in 2005?
Keep it short and to the point. 4.83. What is the difference between the Population (in %) of Guinea-Bissau in 2003 and the Population (in %) of Japan in 2005?
Offer a very short reply. 29.3. What is the difference between the Population (in %) of East Asia (all income levels) in 2004 and the Population (in %) of Europe(all income levels) in 2005?
Make the answer very short. 5.13. What is the difference between the Population (in %) of East Asia (all income levels) in 2004 and the Population (in %) of Guinea-Bissau in 2005?
Your response must be concise. -19.44. What is the difference between the Population (in %) in East Asia (all income levels) in 2004 and the Population (in %) in Japan in 2005?
Offer a very short reply. 9.33. What is the difference between the Population (in %) in Europe(all income levels) in 2004 and the Population (in %) in Guinea-Bissau in 2005?
Offer a very short reply. -24.28. What is the difference between the Population (in %) in Europe(all income levels) in 2004 and the Population (in %) in Japan in 2005?
Provide a short and direct response. 4.49. What is the difference between the Population (in %) of Guinea-Bissau in 2004 and the Population (in %) of Japan in 2005?
Make the answer very short. 29.05. What is the average Population (in %) in East Asia (all income levels) per year?
Give a very brief answer. 24.94. What is the average Population (in %) in Europe(all income levels) per year?
Give a very brief answer. 19.22. What is the average Population (in %) in Guinea-Bissau per year?
Your answer should be compact. 43.44. What is the average Population (in %) in Japan per year?
Give a very brief answer. 14.39. In the year 1998, what is the difference between the Population (in %) in East Asia (all income levels) and Population (in %) in Europe(all income levels)?
Make the answer very short. 6.69. In the year 1998, what is the difference between the Population (in %) of East Asia (all income levels) and Population (in %) of Guinea-Bissau?
Provide a succinct answer. -17.13. In the year 1998, what is the difference between the Population (in %) of East Asia (all income levels) and Population (in %) of Japan?
Your response must be concise. 12.09. In the year 1998, what is the difference between the Population (in %) of Europe(all income levels) and Population (in %) of Guinea-Bissau?
Keep it short and to the point. -23.83. In the year 1998, what is the difference between the Population (in %) in Europe(all income levels) and Population (in %) in Japan?
Provide a short and direct response. 5.4. In the year 1998, what is the difference between the Population (in %) of Guinea-Bissau and Population (in %) of Japan?
Make the answer very short. 29.23. In the year 1999, what is the difference between the Population (in %) in East Asia (all income levels) and Population (in %) in Europe(all income levels)?
Your answer should be compact. 6.54. In the year 1999, what is the difference between the Population (in %) in East Asia (all income levels) and Population (in %) in Guinea-Bissau?
Your answer should be compact. -17.35. In the year 1999, what is the difference between the Population (in %) of East Asia (all income levels) and Population (in %) of Japan?
Your response must be concise. 11.84. In the year 1999, what is the difference between the Population (in %) in Europe(all income levels) and Population (in %) in Guinea-Bissau?
Keep it short and to the point. -23.89. In the year 1999, what is the difference between the Population (in %) in Europe(all income levels) and Population (in %) in Japan?
Provide a succinct answer. 5.3. In the year 1999, what is the difference between the Population (in %) in Guinea-Bissau and Population (in %) in Japan?
Keep it short and to the point. 29.19. In the year 2000, what is the difference between the Population (in %) of East Asia (all income levels) and Population (in %) of Europe(all income levels)?
Offer a very short reply. 6.3. In the year 2000, what is the difference between the Population (in %) in East Asia (all income levels) and Population (in %) in Guinea-Bissau?
Offer a very short reply. -17.68. In the year 2000, what is the difference between the Population (in %) in East Asia (all income levels) and Population (in %) in Japan?
Your answer should be compact. 11.44. In the year 2000, what is the difference between the Population (in %) of Europe(all income levels) and Population (in %) of Guinea-Bissau?
Provide a short and direct response. -23.98. In the year 2000, what is the difference between the Population (in %) of Europe(all income levels) and Population (in %) of Japan?
Ensure brevity in your answer.  5.14. In the year 2000, what is the difference between the Population (in %) in Guinea-Bissau and Population (in %) in Japan?
Your answer should be very brief. 29.12. In the year 2001, what is the difference between the Population (in %) of East Asia (all income levels) and Population (in %) of Europe(all income levels)?
Offer a terse response. 5.99. In the year 2001, what is the difference between the Population (in %) in East Asia (all income levels) and Population (in %) in Guinea-Bissau?
Offer a terse response. -18.15. In the year 2001, what is the difference between the Population (in %) of East Asia (all income levels) and Population (in %) of Japan?
Provide a short and direct response. 10.96. In the year 2001, what is the difference between the Population (in %) in Europe(all income levels) and Population (in %) in Guinea-Bissau?
Make the answer very short. -24.15. In the year 2001, what is the difference between the Population (in %) in Europe(all income levels) and Population (in %) in Japan?
Your response must be concise. 4.97. In the year 2001, what is the difference between the Population (in %) of Guinea-Bissau and Population (in %) of Japan?
Give a very brief answer. 29.11. In the year 2002, what is the difference between the Population (in %) of East Asia (all income levels) and Population (in %) of Europe(all income levels)?
Give a very brief answer. 5.64. In the year 2002, what is the difference between the Population (in %) in East Asia (all income levels) and Population (in %) in Guinea-Bissau?
Offer a terse response. -18.67. In the year 2002, what is the difference between the Population (in %) of East Asia (all income levels) and Population (in %) of Japan?
Keep it short and to the point. 10.41. In the year 2002, what is the difference between the Population (in %) of Europe(all income levels) and Population (in %) of Guinea-Bissau?
Ensure brevity in your answer.  -24.32. In the year 2002, what is the difference between the Population (in %) of Europe(all income levels) and Population (in %) of Japan?
Make the answer very short. 4.77. In the year 2002, what is the difference between the Population (in %) of Guinea-Bissau and Population (in %) of Japan?
Provide a succinct answer. 29.08. In the year 2003, what is the difference between the Population (in %) of East Asia (all income levels) and Population (in %) of Europe(all income levels)?
Offer a very short reply. 5.25. In the year 2003, what is the difference between the Population (in %) of East Asia (all income levels) and Population (in %) of Guinea-Bissau?
Provide a succinct answer. -19.22. In the year 2003, what is the difference between the Population (in %) in East Asia (all income levels) and Population (in %) in Japan?
Ensure brevity in your answer.  9.8. In the year 2003, what is the difference between the Population (in %) of Europe(all income levels) and Population (in %) of Guinea-Bissau?
Make the answer very short. -24.47. In the year 2003, what is the difference between the Population (in %) in Europe(all income levels) and Population (in %) in Japan?
Offer a very short reply. 4.55. In the year 2003, what is the difference between the Population (in %) in Guinea-Bissau and Population (in %) in Japan?
Offer a terse response. 29.02. In the year 2004, what is the difference between the Population (in %) in East Asia (all income levels) and Population (in %) in Europe(all income levels)?
Provide a short and direct response. 4.84. In the year 2004, what is the difference between the Population (in %) of East Asia (all income levels) and Population (in %) of Guinea-Bissau?
Provide a short and direct response. -19.72. In the year 2004, what is the difference between the Population (in %) in East Asia (all income levels) and Population (in %) in Japan?
Give a very brief answer. 9.2. In the year 2004, what is the difference between the Population (in %) of Europe(all income levels) and Population (in %) of Guinea-Bissau?
Offer a very short reply. -24.56. In the year 2004, what is the difference between the Population (in %) of Europe(all income levels) and Population (in %) of Japan?
Your response must be concise. 4.35. In the year 2004, what is the difference between the Population (in %) in Guinea-Bissau and Population (in %) in Japan?
Offer a terse response. 28.92. In the year 2005, what is the difference between the Population (in %) in East Asia (all income levels) and Population (in %) in Europe(all income levels)?
Your answer should be very brief. 4.44. In the year 2005, what is the difference between the Population (in %) in East Asia (all income levels) and Population (in %) in Guinea-Bissau?
Give a very brief answer. -20.13. In the year 2005, what is the difference between the Population (in %) in East Asia (all income levels) and Population (in %) in Japan?
Your answer should be very brief. 8.64. In the year 2005, what is the difference between the Population (in %) in Europe(all income levels) and Population (in %) in Guinea-Bissau?
Provide a succinct answer. -24.56. In the year 2005, what is the difference between the Population (in %) in Europe(all income levels) and Population (in %) in Japan?
Your answer should be compact. 4.2. In the year 2005, what is the difference between the Population (in %) in Guinea-Bissau and Population (in %) in Japan?
Provide a succinct answer. 28.77. What is the ratio of the Population (in %) in East Asia (all income levels) in 1998 to that in 1999?
Provide a short and direct response. 1.02. What is the ratio of the Population (in %) of Europe(all income levels) in 1998 to that in 1999?
Make the answer very short. 1.02. What is the ratio of the Population (in %) in Guinea-Bissau in 1998 to that in 1999?
Your answer should be compact. 1.01. What is the ratio of the Population (in %) of Japan in 1998 to that in 1999?
Ensure brevity in your answer.  1.02. What is the ratio of the Population (in %) in East Asia (all income levels) in 1998 to that in 2000?
Provide a short and direct response. 1.04. What is the ratio of the Population (in %) in Europe(all income levels) in 1998 to that in 2000?
Your answer should be compact. 1.04. What is the ratio of the Population (in %) in Guinea-Bissau in 1998 to that in 2000?
Make the answer very short. 1.01. What is the ratio of the Population (in %) of Japan in 1998 to that in 2000?
Your response must be concise. 1.03. What is the ratio of the Population (in %) in East Asia (all income levels) in 1998 to that in 2001?
Provide a succinct answer. 1.07. What is the ratio of the Population (in %) of Europe(all income levels) in 1998 to that in 2001?
Make the answer very short. 1.06. What is the ratio of the Population (in %) of Guinea-Bissau in 1998 to that in 2001?
Make the answer very short. 1.02. What is the ratio of the Population (in %) in Japan in 1998 to that in 2001?
Ensure brevity in your answer.  1.05. What is the ratio of the Population (in %) in East Asia (all income levels) in 1998 to that in 2002?
Keep it short and to the point. 1.1. What is the ratio of the Population (in %) of Europe(all income levels) in 1998 to that in 2002?
Your response must be concise. 1.08. What is the ratio of the Population (in %) in Guinea-Bissau in 1998 to that in 2002?
Provide a short and direct response. 1.02. What is the ratio of the Population (in %) in Japan in 1998 to that in 2002?
Offer a terse response. 1.06. What is the ratio of the Population (in %) of East Asia (all income levels) in 1998 to that in 2003?
Keep it short and to the point. 1.14. What is the ratio of the Population (in %) in Europe(all income levels) in 1998 to that in 2003?
Your response must be concise. 1.1. What is the ratio of the Population (in %) in Guinea-Bissau in 1998 to that in 2003?
Your response must be concise. 1.03. What is the ratio of the Population (in %) of Japan in 1998 to that in 2003?
Ensure brevity in your answer.  1.07. What is the ratio of the Population (in %) of East Asia (all income levels) in 1998 to that in 2004?
Your answer should be very brief. 1.18. What is the ratio of the Population (in %) in Europe(all income levels) in 1998 to that in 2004?
Your response must be concise. 1.12. What is the ratio of the Population (in %) of Guinea-Bissau in 1998 to that in 2004?
Offer a terse response. 1.03. What is the ratio of the Population (in %) in Japan in 1998 to that in 2004?
Ensure brevity in your answer.  1.08. What is the ratio of the Population (in %) in East Asia (all income levels) in 1998 to that in 2005?
Your answer should be very brief. 1.21. What is the ratio of the Population (in %) in Europe(all income levels) in 1998 to that in 2005?
Give a very brief answer. 1.14. What is the ratio of the Population (in %) in Guinea-Bissau in 1998 to that in 2005?
Your answer should be compact. 1.04. What is the ratio of the Population (in %) of Japan in 1998 to that in 2005?
Provide a short and direct response. 1.1. What is the ratio of the Population (in %) of East Asia (all income levels) in 1999 to that in 2000?
Offer a very short reply. 1.02. What is the ratio of the Population (in %) in Europe(all income levels) in 1999 to that in 2000?
Keep it short and to the point. 1.02. What is the ratio of the Population (in %) in Guinea-Bissau in 1999 to that in 2000?
Your answer should be compact. 1.01. What is the ratio of the Population (in %) of Japan in 1999 to that in 2000?
Offer a terse response. 1.02. What is the ratio of the Population (in %) of East Asia (all income levels) in 1999 to that in 2001?
Offer a very short reply. 1.05. What is the ratio of the Population (in %) in Europe(all income levels) in 1999 to that in 2001?
Make the answer very short. 1.04. What is the ratio of the Population (in %) in Guinea-Bissau in 1999 to that in 2001?
Your response must be concise. 1.01. What is the ratio of the Population (in %) of Japan in 1999 to that in 2001?
Ensure brevity in your answer.  1.03. What is the ratio of the Population (in %) of East Asia (all income levels) in 1999 to that in 2002?
Offer a very short reply. 1.08. What is the ratio of the Population (in %) of Europe(all income levels) in 1999 to that in 2002?
Keep it short and to the point. 1.06. What is the ratio of the Population (in %) in Guinea-Bissau in 1999 to that in 2002?
Your response must be concise. 1.02. What is the ratio of the Population (in %) in Japan in 1999 to that in 2002?
Keep it short and to the point. 1.04. What is the ratio of the Population (in %) of East Asia (all income levels) in 1999 to that in 2003?
Offer a very short reply. 1.12. What is the ratio of the Population (in %) of Europe(all income levels) in 1999 to that in 2003?
Provide a short and direct response. 1.08. What is the ratio of the Population (in %) of Guinea-Bissau in 1999 to that in 2003?
Your response must be concise. 1.02. What is the ratio of the Population (in %) in Japan in 1999 to that in 2003?
Give a very brief answer. 1.05. What is the ratio of the Population (in %) of East Asia (all income levels) in 1999 to that in 2004?
Offer a terse response. 1.15. What is the ratio of the Population (in %) in Europe(all income levels) in 1999 to that in 2004?
Offer a very short reply. 1.1. What is the ratio of the Population (in %) in Guinea-Bissau in 1999 to that in 2004?
Provide a short and direct response. 1.03. What is the ratio of the Population (in %) in Japan in 1999 to that in 2004?
Keep it short and to the point. 1.07. What is the ratio of the Population (in %) of East Asia (all income levels) in 1999 to that in 2005?
Your answer should be very brief. 1.19. What is the ratio of the Population (in %) of Europe(all income levels) in 1999 to that in 2005?
Make the answer very short. 1.12. What is the ratio of the Population (in %) in Guinea-Bissau in 1999 to that in 2005?
Offer a very short reply. 1.03. What is the ratio of the Population (in %) of Japan in 1999 to that in 2005?
Give a very brief answer. 1.08. What is the ratio of the Population (in %) of East Asia (all income levels) in 2000 to that in 2001?
Offer a terse response. 1.03. What is the ratio of the Population (in %) of Europe(all income levels) in 2000 to that in 2001?
Your answer should be compact. 1.02. What is the ratio of the Population (in %) in Guinea-Bissau in 2000 to that in 2001?
Ensure brevity in your answer.  1. What is the ratio of the Population (in %) of Japan in 2000 to that in 2001?
Offer a very short reply. 1.01. What is the ratio of the Population (in %) in East Asia (all income levels) in 2000 to that in 2002?
Offer a very short reply. 1.06. What is the ratio of the Population (in %) in Europe(all income levels) in 2000 to that in 2002?
Keep it short and to the point. 1.04. What is the ratio of the Population (in %) of Guinea-Bissau in 2000 to that in 2002?
Offer a terse response. 1.01. What is the ratio of the Population (in %) of Japan in 2000 to that in 2002?
Ensure brevity in your answer.  1.03. What is the ratio of the Population (in %) in East Asia (all income levels) in 2000 to that in 2003?
Your answer should be compact. 1.09. What is the ratio of the Population (in %) of Europe(all income levels) in 2000 to that in 2003?
Provide a short and direct response. 1.06. What is the ratio of the Population (in %) of Guinea-Bissau in 2000 to that in 2003?
Your response must be concise. 1.01. What is the ratio of the Population (in %) of Japan in 2000 to that in 2003?
Give a very brief answer. 1.04. What is the ratio of the Population (in %) of East Asia (all income levels) in 2000 to that in 2004?
Ensure brevity in your answer.  1.13. What is the ratio of the Population (in %) of Europe(all income levels) in 2000 to that in 2004?
Provide a short and direct response. 1.08. What is the ratio of the Population (in %) of Guinea-Bissau in 2000 to that in 2004?
Offer a terse response. 1.02. What is the ratio of the Population (in %) in Japan in 2000 to that in 2004?
Give a very brief answer. 1.05. What is the ratio of the Population (in %) of East Asia (all income levels) in 2000 to that in 2005?
Ensure brevity in your answer.  1.16. What is the ratio of the Population (in %) in Europe(all income levels) in 2000 to that in 2005?
Provide a short and direct response. 1.1. What is the ratio of the Population (in %) in Guinea-Bissau in 2000 to that in 2005?
Your answer should be very brief. 1.03. What is the ratio of the Population (in %) in Japan in 2000 to that in 2005?
Provide a short and direct response. 1.06. What is the ratio of the Population (in %) of East Asia (all income levels) in 2001 to that in 2002?
Keep it short and to the point. 1.03. What is the ratio of the Population (in %) in Europe(all income levels) in 2001 to that in 2002?
Provide a succinct answer. 1.02. What is the ratio of the Population (in %) in Japan in 2001 to that in 2002?
Offer a terse response. 1.01. What is the ratio of the Population (in %) in East Asia (all income levels) in 2001 to that in 2003?
Give a very brief answer. 1.06. What is the ratio of the Population (in %) of Europe(all income levels) in 2001 to that in 2003?
Provide a succinct answer. 1.04. What is the ratio of the Population (in %) of Guinea-Bissau in 2001 to that in 2003?
Provide a succinct answer. 1.01. What is the ratio of the Population (in %) in East Asia (all income levels) in 2001 to that in 2004?
Offer a very short reply. 1.1. What is the ratio of the Population (in %) of Europe(all income levels) in 2001 to that in 2004?
Your answer should be very brief. 1.06. What is the ratio of the Population (in %) in Guinea-Bissau in 2001 to that in 2004?
Offer a very short reply. 1.02. What is the ratio of the Population (in %) of Japan in 2001 to that in 2004?
Make the answer very short. 1.04. What is the ratio of the Population (in %) in East Asia (all income levels) in 2001 to that in 2005?
Make the answer very short. 1.13. What is the ratio of the Population (in %) in Europe(all income levels) in 2001 to that in 2005?
Offer a terse response. 1.08. What is the ratio of the Population (in %) of Guinea-Bissau in 2001 to that in 2005?
Give a very brief answer. 1.02. What is the ratio of the Population (in %) in Japan in 2001 to that in 2005?
Make the answer very short. 1.05. What is the ratio of the Population (in %) of East Asia (all income levels) in 2002 to that in 2003?
Give a very brief answer. 1.03. What is the ratio of the Population (in %) of Europe(all income levels) in 2002 to that in 2003?
Offer a very short reply. 1.02. What is the ratio of the Population (in %) in Guinea-Bissau in 2002 to that in 2003?
Your response must be concise. 1.01. What is the ratio of the Population (in %) in Japan in 2002 to that in 2003?
Offer a terse response. 1.01. What is the ratio of the Population (in %) in East Asia (all income levels) in 2002 to that in 2004?
Ensure brevity in your answer.  1.07. What is the ratio of the Population (in %) in Guinea-Bissau in 2002 to that in 2004?
Offer a terse response. 1.01. What is the ratio of the Population (in %) of Japan in 2002 to that in 2004?
Provide a short and direct response. 1.02. What is the ratio of the Population (in %) of East Asia (all income levels) in 2002 to that in 2005?
Make the answer very short. 1.1. What is the ratio of the Population (in %) in Europe(all income levels) in 2002 to that in 2005?
Offer a very short reply. 1.06. What is the ratio of the Population (in %) of Guinea-Bissau in 2002 to that in 2005?
Offer a terse response. 1.02. What is the ratio of the Population (in %) of Japan in 2002 to that in 2005?
Offer a very short reply. 1.03. What is the ratio of the Population (in %) in East Asia (all income levels) in 2003 to that in 2004?
Your answer should be compact. 1.03. What is the ratio of the Population (in %) in Europe(all income levels) in 2003 to that in 2004?
Give a very brief answer. 1.02. What is the ratio of the Population (in %) of Japan in 2003 to that in 2004?
Your response must be concise. 1.01. What is the ratio of the Population (in %) of East Asia (all income levels) in 2003 to that in 2005?
Your answer should be very brief. 1.06. What is the ratio of the Population (in %) in Europe(all income levels) in 2003 to that in 2005?
Your answer should be compact. 1.03. What is the ratio of the Population (in %) of Guinea-Bissau in 2003 to that in 2005?
Keep it short and to the point. 1.01. What is the ratio of the Population (in %) of Japan in 2003 to that in 2005?
Your answer should be very brief. 1.02. What is the ratio of the Population (in %) in East Asia (all income levels) in 2004 to that in 2005?
Your answer should be very brief. 1.03. What is the ratio of the Population (in %) in Europe(all income levels) in 2004 to that in 2005?
Give a very brief answer. 1.02. What is the ratio of the Population (in %) of Guinea-Bissau in 2004 to that in 2005?
Ensure brevity in your answer.  1.01. What is the ratio of the Population (in %) in Japan in 2004 to that in 2005?
Your answer should be very brief. 1.01. What is the difference between the highest and the second highest Population (in %) in East Asia (all income levels)?
Give a very brief answer. 0.51. What is the difference between the highest and the second highest Population (in %) of Europe(all income levels)?
Provide a short and direct response. 0.36. What is the difference between the highest and the second highest Population (in %) in Guinea-Bissau?
Your answer should be compact. 0.3. What is the difference between the highest and the second highest Population (in %) of Japan?
Ensure brevity in your answer.  0.26. What is the difference between the highest and the lowest Population (in %) of East Asia (all income levels)?
Your answer should be compact. 4.77. What is the difference between the highest and the lowest Population (in %) in Europe(all income levels)?
Provide a short and direct response. 2.51. What is the difference between the highest and the lowest Population (in %) in Guinea-Bissau?
Keep it short and to the point. 1.78. What is the difference between the highest and the lowest Population (in %) of Japan?
Your answer should be compact. 1.31. 